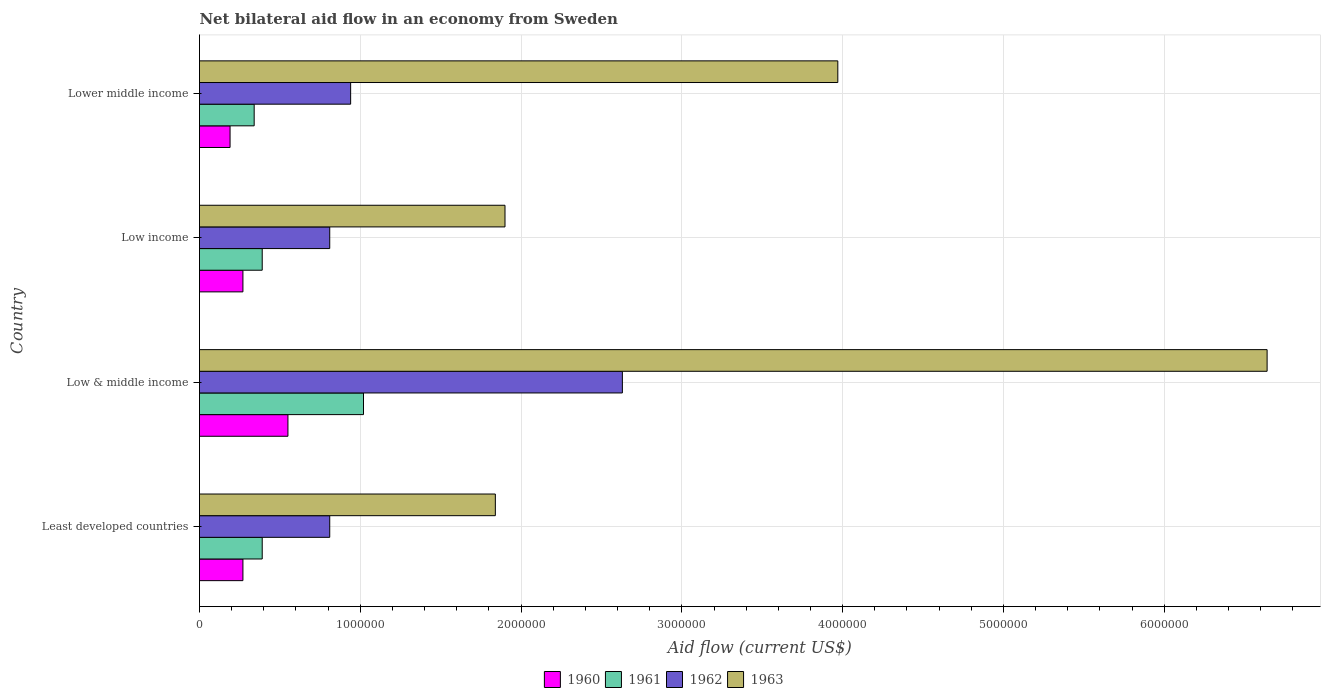How many groups of bars are there?
Provide a succinct answer. 4. Are the number of bars per tick equal to the number of legend labels?
Provide a short and direct response. Yes. Are the number of bars on each tick of the Y-axis equal?
Make the answer very short. Yes. How many bars are there on the 2nd tick from the bottom?
Provide a succinct answer. 4. What is the label of the 2nd group of bars from the top?
Give a very brief answer. Low income. What is the net bilateral aid flow in 1962 in Least developed countries?
Your response must be concise. 8.10e+05. Across all countries, what is the minimum net bilateral aid flow in 1960?
Ensure brevity in your answer.  1.90e+05. In which country was the net bilateral aid flow in 1963 minimum?
Ensure brevity in your answer.  Least developed countries. What is the total net bilateral aid flow in 1960 in the graph?
Your answer should be compact. 1.28e+06. What is the difference between the net bilateral aid flow in 1961 in Low income and that in Lower middle income?
Keep it short and to the point. 5.00e+04. What is the difference between the net bilateral aid flow in 1963 in Lower middle income and the net bilateral aid flow in 1962 in Low income?
Offer a very short reply. 3.16e+06. What is the average net bilateral aid flow in 1963 per country?
Provide a succinct answer. 3.59e+06. What is the difference between the net bilateral aid flow in 1960 and net bilateral aid flow in 1963 in Low & middle income?
Offer a terse response. -6.09e+06. In how many countries, is the net bilateral aid flow in 1963 greater than 800000 US$?
Provide a short and direct response. 4. What is the ratio of the net bilateral aid flow in 1963 in Least developed countries to that in Low income?
Provide a succinct answer. 0.97. Is the net bilateral aid flow in 1961 in Least developed countries less than that in Low & middle income?
Offer a terse response. Yes. What is the difference between the highest and the second highest net bilateral aid flow in 1961?
Your answer should be compact. 6.30e+05. What is the difference between the highest and the lowest net bilateral aid flow in 1961?
Make the answer very short. 6.80e+05. Is the sum of the net bilateral aid flow in 1963 in Least developed countries and Low income greater than the maximum net bilateral aid flow in 1961 across all countries?
Give a very brief answer. Yes. Is it the case that in every country, the sum of the net bilateral aid flow in 1963 and net bilateral aid flow in 1961 is greater than the sum of net bilateral aid flow in 1962 and net bilateral aid flow in 1960?
Provide a short and direct response. No. What does the 4th bar from the top in Least developed countries represents?
Offer a terse response. 1960. Is it the case that in every country, the sum of the net bilateral aid flow in 1961 and net bilateral aid flow in 1963 is greater than the net bilateral aid flow in 1960?
Provide a succinct answer. Yes. Are all the bars in the graph horizontal?
Make the answer very short. Yes. How many countries are there in the graph?
Offer a very short reply. 4. What is the difference between two consecutive major ticks on the X-axis?
Your response must be concise. 1.00e+06. Does the graph contain grids?
Give a very brief answer. Yes. Where does the legend appear in the graph?
Your answer should be compact. Bottom center. How are the legend labels stacked?
Offer a terse response. Horizontal. What is the title of the graph?
Provide a succinct answer. Net bilateral aid flow in an economy from Sweden. What is the Aid flow (current US$) in 1962 in Least developed countries?
Your answer should be compact. 8.10e+05. What is the Aid flow (current US$) in 1963 in Least developed countries?
Provide a short and direct response. 1.84e+06. What is the Aid flow (current US$) of 1961 in Low & middle income?
Provide a succinct answer. 1.02e+06. What is the Aid flow (current US$) of 1962 in Low & middle income?
Your answer should be compact. 2.63e+06. What is the Aid flow (current US$) in 1963 in Low & middle income?
Keep it short and to the point. 6.64e+06. What is the Aid flow (current US$) of 1960 in Low income?
Offer a very short reply. 2.70e+05. What is the Aid flow (current US$) of 1961 in Low income?
Your answer should be very brief. 3.90e+05. What is the Aid flow (current US$) of 1962 in Low income?
Keep it short and to the point. 8.10e+05. What is the Aid flow (current US$) of 1963 in Low income?
Provide a short and direct response. 1.90e+06. What is the Aid flow (current US$) of 1961 in Lower middle income?
Provide a succinct answer. 3.40e+05. What is the Aid flow (current US$) of 1962 in Lower middle income?
Offer a very short reply. 9.40e+05. What is the Aid flow (current US$) in 1963 in Lower middle income?
Offer a terse response. 3.97e+06. Across all countries, what is the maximum Aid flow (current US$) in 1960?
Make the answer very short. 5.50e+05. Across all countries, what is the maximum Aid flow (current US$) in 1961?
Offer a terse response. 1.02e+06. Across all countries, what is the maximum Aid flow (current US$) of 1962?
Offer a very short reply. 2.63e+06. Across all countries, what is the maximum Aid flow (current US$) of 1963?
Your answer should be compact. 6.64e+06. Across all countries, what is the minimum Aid flow (current US$) of 1962?
Offer a very short reply. 8.10e+05. Across all countries, what is the minimum Aid flow (current US$) of 1963?
Your response must be concise. 1.84e+06. What is the total Aid flow (current US$) of 1960 in the graph?
Provide a succinct answer. 1.28e+06. What is the total Aid flow (current US$) of 1961 in the graph?
Keep it short and to the point. 2.14e+06. What is the total Aid flow (current US$) in 1962 in the graph?
Provide a short and direct response. 5.19e+06. What is the total Aid flow (current US$) in 1963 in the graph?
Make the answer very short. 1.44e+07. What is the difference between the Aid flow (current US$) in 1960 in Least developed countries and that in Low & middle income?
Make the answer very short. -2.80e+05. What is the difference between the Aid flow (current US$) in 1961 in Least developed countries and that in Low & middle income?
Offer a very short reply. -6.30e+05. What is the difference between the Aid flow (current US$) in 1962 in Least developed countries and that in Low & middle income?
Your answer should be compact. -1.82e+06. What is the difference between the Aid flow (current US$) in 1963 in Least developed countries and that in Low & middle income?
Your response must be concise. -4.80e+06. What is the difference between the Aid flow (current US$) in 1960 in Least developed countries and that in Low income?
Ensure brevity in your answer.  0. What is the difference between the Aid flow (current US$) of 1960 in Least developed countries and that in Lower middle income?
Your response must be concise. 8.00e+04. What is the difference between the Aid flow (current US$) in 1961 in Least developed countries and that in Lower middle income?
Provide a succinct answer. 5.00e+04. What is the difference between the Aid flow (current US$) of 1963 in Least developed countries and that in Lower middle income?
Make the answer very short. -2.13e+06. What is the difference between the Aid flow (current US$) in 1961 in Low & middle income and that in Low income?
Keep it short and to the point. 6.30e+05. What is the difference between the Aid flow (current US$) in 1962 in Low & middle income and that in Low income?
Ensure brevity in your answer.  1.82e+06. What is the difference between the Aid flow (current US$) of 1963 in Low & middle income and that in Low income?
Offer a terse response. 4.74e+06. What is the difference between the Aid flow (current US$) of 1960 in Low & middle income and that in Lower middle income?
Offer a terse response. 3.60e+05. What is the difference between the Aid flow (current US$) in 1961 in Low & middle income and that in Lower middle income?
Keep it short and to the point. 6.80e+05. What is the difference between the Aid flow (current US$) in 1962 in Low & middle income and that in Lower middle income?
Your answer should be very brief. 1.69e+06. What is the difference between the Aid flow (current US$) of 1963 in Low & middle income and that in Lower middle income?
Offer a terse response. 2.67e+06. What is the difference between the Aid flow (current US$) in 1961 in Low income and that in Lower middle income?
Provide a succinct answer. 5.00e+04. What is the difference between the Aid flow (current US$) of 1963 in Low income and that in Lower middle income?
Make the answer very short. -2.07e+06. What is the difference between the Aid flow (current US$) in 1960 in Least developed countries and the Aid flow (current US$) in 1961 in Low & middle income?
Offer a very short reply. -7.50e+05. What is the difference between the Aid flow (current US$) in 1960 in Least developed countries and the Aid flow (current US$) in 1962 in Low & middle income?
Offer a very short reply. -2.36e+06. What is the difference between the Aid flow (current US$) of 1960 in Least developed countries and the Aid flow (current US$) of 1963 in Low & middle income?
Offer a terse response. -6.37e+06. What is the difference between the Aid flow (current US$) of 1961 in Least developed countries and the Aid flow (current US$) of 1962 in Low & middle income?
Make the answer very short. -2.24e+06. What is the difference between the Aid flow (current US$) in 1961 in Least developed countries and the Aid flow (current US$) in 1963 in Low & middle income?
Offer a terse response. -6.25e+06. What is the difference between the Aid flow (current US$) of 1962 in Least developed countries and the Aid flow (current US$) of 1963 in Low & middle income?
Give a very brief answer. -5.83e+06. What is the difference between the Aid flow (current US$) of 1960 in Least developed countries and the Aid flow (current US$) of 1962 in Low income?
Offer a very short reply. -5.40e+05. What is the difference between the Aid flow (current US$) in 1960 in Least developed countries and the Aid flow (current US$) in 1963 in Low income?
Provide a succinct answer. -1.63e+06. What is the difference between the Aid flow (current US$) in 1961 in Least developed countries and the Aid flow (current US$) in 1962 in Low income?
Offer a terse response. -4.20e+05. What is the difference between the Aid flow (current US$) in 1961 in Least developed countries and the Aid flow (current US$) in 1963 in Low income?
Provide a succinct answer. -1.51e+06. What is the difference between the Aid flow (current US$) in 1962 in Least developed countries and the Aid flow (current US$) in 1963 in Low income?
Offer a terse response. -1.09e+06. What is the difference between the Aid flow (current US$) in 1960 in Least developed countries and the Aid flow (current US$) in 1962 in Lower middle income?
Your answer should be compact. -6.70e+05. What is the difference between the Aid flow (current US$) in 1960 in Least developed countries and the Aid flow (current US$) in 1963 in Lower middle income?
Your answer should be very brief. -3.70e+06. What is the difference between the Aid flow (current US$) of 1961 in Least developed countries and the Aid flow (current US$) of 1962 in Lower middle income?
Your response must be concise. -5.50e+05. What is the difference between the Aid flow (current US$) of 1961 in Least developed countries and the Aid flow (current US$) of 1963 in Lower middle income?
Your answer should be very brief. -3.58e+06. What is the difference between the Aid flow (current US$) of 1962 in Least developed countries and the Aid flow (current US$) of 1963 in Lower middle income?
Offer a very short reply. -3.16e+06. What is the difference between the Aid flow (current US$) of 1960 in Low & middle income and the Aid flow (current US$) of 1961 in Low income?
Your answer should be compact. 1.60e+05. What is the difference between the Aid flow (current US$) of 1960 in Low & middle income and the Aid flow (current US$) of 1962 in Low income?
Ensure brevity in your answer.  -2.60e+05. What is the difference between the Aid flow (current US$) of 1960 in Low & middle income and the Aid flow (current US$) of 1963 in Low income?
Keep it short and to the point. -1.35e+06. What is the difference between the Aid flow (current US$) in 1961 in Low & middle income and the Aid flow (current US$) in 1963 in Low income?
Your response must be concise. -8.80e+05. What is the difference between the Aid flow (current US$) of 1962 in Low & middle income and the Aid flow (current US$) of 1963 in Low income?
Make the answer very short. 7.30e+05. What is the difference between the Aid flow (current US$) in 1960 in Low & middle income and the Aid flow (current US$) in 1961 in Lower middle income?
Ensure brevity in your answer.  2.10e+05. What is the difference between the Aid flow (current US$) in 1960 in Low & middle income and the Aid flow (current US$) in 1962 in Lower middle income?
Provide a short and direct response. -3.90e+05. What is the difference between the Aid flow (current US$) in 1960 in Low & middle income and the Aid flow (current US$) in 1963 in Lower middle income?
Your response must be concise. -3.42e+06. What is the difference between the Aid flow (current US$) in 1961 in Low & middle income and the Aid flow (current US$) in 1962 in Lower middle income?
Your response must be concise. 8.00e+04. What is the difference between the Aid flow (current US$) in 1961 in Low & middle income and the Aid flow (current US$) in 1963 in Lower middle income?
Provide a succinct answer. -2.95e+06. What is the difference between the Aid flow (current US$) in 1962 in Low & middle income and the Aid flow (current US$) in 1963 in Lower middle income?
Make the answer very short. -1.34e+06. What is the difference between the Aid flow (current US$) of 1960 in Low income and the Aid flow (current US$) of 1961 in Lower middle income?
Keep it short and to the point. -7.00e+04. What is the difference between the Aid flow (current US$) in 1960 in Low income and the Aid flow (current US$) in 1962 in Lower middle income?
Your response must be concise. -6.70e+05. What is the difference between the Aid flow (current US$) in 1960 in Low income and the Aid flow (current US$) in 1963 in Lower middle income?
Your response must be concise. -3.70e+06. What is the difference between the Aid flow (current US$) of 1961 in Low income and the Aid flow (current US$) of 1962 in Lower middle income?
Make the answer very short. -5.50e+05. What is the difference between the Aid flow (current US$) in 1961 in Low income and the Aid flow (current US$) in 1963 in Lower middle income?
Your answer should be compact. -3.58e+06. What is the difference between the Aid flow (current US$) of 1962 in Low income and the Aid flow (current US$) of 1963 in Lower middle income?
Your answer should be compact. -3.16e+06. What is the average Aid flow (current US$) in 1961 per country?
Make the answer very short. 5.35e+05. What is the average Aid flow (current US$) in 1962 per country?
Your response must be concise. 1.30e+06. What is the average Aid flow (current US$) in 1963 per country?
Make the answer very short. 3.59e+06. What is the difference between the Aid flow (current US$) in 1960 and Aid flow (current US$) in 1961 in Least developed countries?
Keep it short and to the point. -1.20e+05. What is the difference between the Aid flow (current US$) of 1960 and Aid flow (current US$) of 1962 in Least developed countries?
Offer a very short reply. -5.40e+05. What is the difference between the Aid flow (current US$) of 1960 and Aid flow (current US$) of 1963 in Least developed countries?
Give a very brief answer. -1.57e+06. What is the difference between the Aid flow (current US$) in 1961 and Aid flow (current US$) in 1962 in Least developed countries?
Your answer should be very brief. -4.20e+05. What is the difference between the Aid flow (current US$) of 1961 and Aid flow (current US$) of 1963 in Least developed countries?
Give a very brief answer. -1.45e+06. What is the difference between the Aid flow (current US$) in 1962 and Aid flow (current US$) in 1963 in Least developed countries?
Offer a very short reply. -1.03e+06. What is the difference between the Aid flow (current US$) in 1960 and Aid flow (current US$) in 1961 in Low & middle income?
Offer a terse response. -4.70e+05. What is the difference between the Aid flow (current US$) of 1960 and Aid flow (current US$) of 1962 in Low & middle income?
Provide a succinct answer. -2.08e+06. What is the difference between the Aid flow (current US$) of 1960 and Aid flow (current US$) of 1963 in Low & middle income?
Your answer should be very brief. -6.09e+06. What is the difference between the Aid flow (current US$) in 1961 and Aid flow (current US$) in 1962 in Low & middle income?
Your response must be concise. -1.61e+06. What is the difference between the Aid flow (current US$) of 1961 and Aid flow (current US$) of 1963 in Low & middle income?
Keep it short and to the point. -5.62e+06. What is the difference between the Aid flow (current US$) in 1962 and Aid flow (current US$) in 1963 in Low & middle income?
Give a very brief answer. -4.01e+06. What is the difference between the Aid flow (current US$) in 1960 and Aid flow (current US$) in 1961 in Low income?
Provide a short and direct response. -1.20e+05. What is the difference between the Aid flow (current US$) in 1960 and Aid flow (current US$) in 1962 in Low income?
Provide a short and direct response. -5.40e+05. What is the difference between the Aid flow (current US$) in 1960 and Aid flow (current US$) in 1963 in Low income?
Offer a very short reply. -1.63e+06. What is the difference between the Aid flow (current US$) of 1961 and Aid flow (current US$) of 1962 in Low income?
Your answer should be very brief. -4.20e+05. What is the difference between the Aid flow (current US$) in 1961 and Aid flow (current US$) in 1963 in Low income?
Provide a succinct answer. -1.51e+06. What is the difference between the Aid flow (current US$) of 1962 and Aid flow (current US$) of 1963 in Low income?
Ensure brevity in your answer.  -1.09e+06. What is the difference between the Aid flow (current US$) in 1960 and Aid flow (current US$) in 1962 in Lower middle income?
Your answer should be compact. -7.50e+05. What is the difference between the Aid flow (current US$) in 1960 and Aid flow (current US$) in 1963 in Lower middle income?
Ensure brevity in your answer.  -3.78e+06. What is the difference between the Aid flow (current US$) of 1961 and Aid flow (current US$) of 1962 in Lower middle income?
Provide a succinct answer. -6.00e+05. What is the difference between the Aid flow (current US$) of 1961 and Aid flow (current US$) of 1963 in Lower middle income?
Your answer should be very brief. -3.63e+06. What is the difference between the Aid flow (current US$) in 1962 and Aid flow (current US$) in 1963 in Lower middle income?
Offer a terse response. -3.03e+06. What is the ratio of the Aid flow (current US$) in 1960 in Least developed countries to that in Low & middle income?
Provide a short and direct response. 0.49. What is the ratio of the Aid flow (current US$) in 1961 in Least developed countries to that in Low & middle income?
Keep it short and to the point. 0.38. What is the ratio of the Aid flow (current US$) in 1962 in Least developed countries to that in Low & middle income?
Keep it short and to the point. 0.31. What is the ratio of the Aid flow (current US$) of 1963 in Least developed countries to that in Low & middle income?
Offer a terse response. 0.28. What is the ratio of the Aid flow (current US$) in 1960 in Least developed countries to that in Low income?
Give a very brief answer. 1. What is the ratio of the Aid flow (current US$) in 1963 in Least developed countries to that in Low income?
Make the answer very short. 0.97. What is the ratio of the Aid flow (current US$) in 1960 in Least developed countries to that in Lower middle income?
Keep it short and to the point. 1.42. What is the ratio of the Aid flow (current US$) of 1961 in Least developed countries to that in Lower middle income?
Offer a very short reply. 1.15. What is the ratio of the Aid flow (current US$) in 1962 in Least developed countries to that in Lower middle income?
Offer a terse response. 0.86. What is the ratio of the Aid flow (current US$) in 1963 in Least developed countries to that in Lower middle income?
Your response must be concise. 0.46. What is the ratio of the Aid flow (current US$) in 1960 in Low & middle income to that in Low income?
Ensure brevity in your answer.  2.04. What is the ratio of the Aid flow (current US$) of 1961 in Low & middle income to that in Low income?
Make the answer very short. 2.62. What is the ratio of the Aid flow (current US$) in 1962 in Low & middle income to that in Low income?
Give a very brief answer. 3.25. What is the ratio of the Aid flow (current US$) in 1963 in Low & middle income to that in Low income?
Your answer should be compact. 3.49. What is the ratio of the Aid flow (current US$) of 1960 in Low & middle income to that in Lower middle income?
Make the answer very short. 2.89. What is the ratio of the Aid flow (current US$) of 1962 in Low & middle income to that in Lower middle income?
Give a very brief answer. 2.8. What is the ratio of the Aid flow (current US$) of 1963 in Low & middle income to that in Lower middle income?
Ensure brevity in your answer.  1.67. What is the ratio of the Aid flow (current US$) of 1960 in Low income to that in Lower middle income?
Give a very brief answer. 1.42. What is the ratio of the Aid flow (current US$) of 1961 in Low income to that in Lower middle income?
Provide a short and direct response. 1.15. What is the ratio of the Aid flow (current US$) of 1962 in Low income to that in Lower middle income?
Provide a short and direct response. 0.86. What is the ratio of the Aid flow (current US$) of 1963 in Low income to that in Lower middle income?
Give a very brief answer. 0.48. What is the difference between the highest and the second highest Aid flow (current US$) in 1961?
Provide a succinct answer. 6.30e+05. What is the difference between the highest and the second highest Aid flow (current US$) of 1962?
Provide a succinct answer. 1.69e+06. What is the difference between the highest and the second highest Aid flow (current US$) in 1963?
Provide a succinct answer. 2.67e+06. What is the difference between the highest and the lowest Aid flow (current US$) of 1961?
Your answer should be compact. 6.80e+05. What is the difference between the highest and the lowest Aid flow (current US$) of 1962?
Offer a very short reply. 1.82e+06. What is the difference between the highest and the lowest Aid flow (current US$) in 1963?
Ensure brevity in your answer.  4.80e+06. 